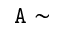Convert formula to latex. <formula><loc_0><loc_0><loc_500><loc_500>\tt { A } \sim</formula> 